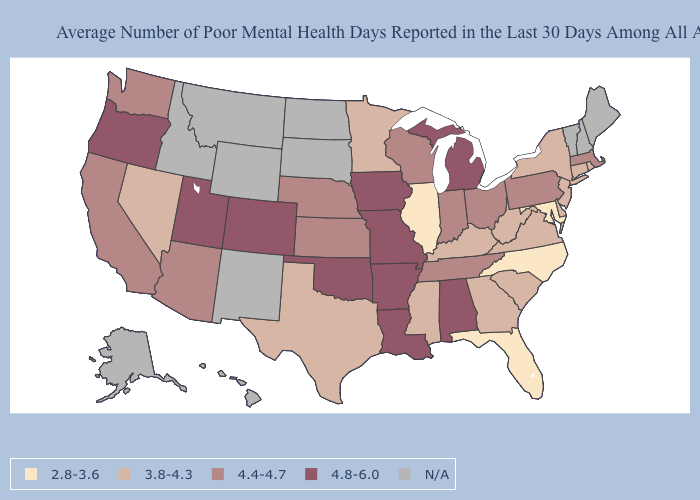Does the first symbol in the legend represent the smallest category?
Quick response, please. Yes. Among the states that border Alabama , does Florida have the lowest value?
Write a very short answer. Yes. What is the value of New Hampshire?
Answer briefly. N/A. Does Massachusetts have the lowest value in the Northeast?
Give a very brief answer. No. Name the states that have a value in the range N/A?
Quick response, please. Alaska, Hawaii, Idaho, Maine, Montana, New Hampshire, New Mexico, North Dakota, South Dakota, Vermont, Wyoming. What is the value of Wisconsin?
Be succinct. 4.4-4.7. Name the states that have a value in the range 4.4-4.7?
Quick response, please. Arizona, California, Indiana, Kansas, Massachusetts, Nebraska, Ohio, Pennsylvania, Tennessee, Washington, Wisconsin. Name the states that have a value in the range 2.8-3.6?
Short answer required. Florida, Illinois, Maryland, North Carolina. Name the states that have a value in the range 4.4-4.7?
Short answer required. Arizona, California, Indiana, Kansas, Massachusetts, Nebraska, Ohio, Pennsylvania, Tennessee, Washington, Wisconsin. What is the value of Utah?
Answer briefly. 4.8-6.0. Which states have the lowest value in the Northeast?
Be succinct. Connecticut, New Jersey, New York, Rhode Island. Which states hav the highest value in the MidWest?
Answer briefly. Iowa, Michigan, Missouri. Does the map have missing data?
Give a very brief answer. Yes. Name the states that have a value in the range 3.8-4.3?
Keep it brief. Connecticut, Delaware, Georgia, Kentucky, Minnesota, Mississippi, Nevada, New Jersey, New York, Rhode Island, South Carolina, Texas, Virginia, West Virginia. What is the value of Tennessee?
Quick response, please. 4.4-4.7. 